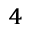Convert formula to latex. <formula><loc_0><loc_0><loc_500><loc_500>_ { 4 }</formula> 